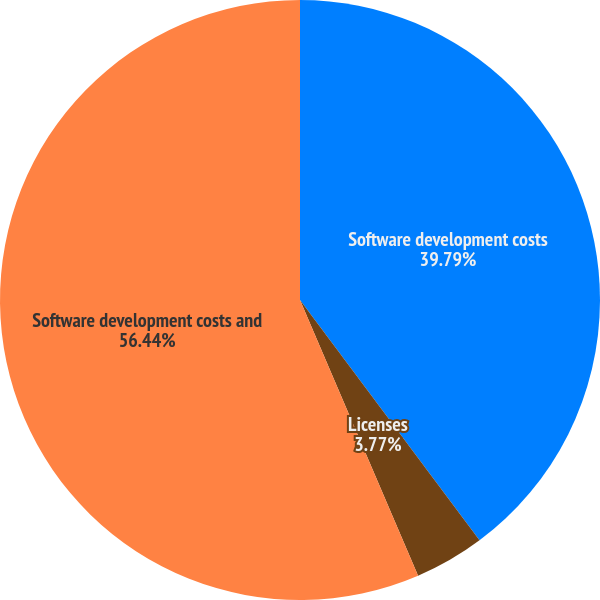Convert chart to OTSL. <chart><loc_0><loc_0><loc_500><loc_500><pie_chart><fcel>Software development costs<fcel>Licenses<fcel>Software development costs and<nl><fcel>39.79%<fcel>3.77%<fcel>56.44%<nl></chart> 